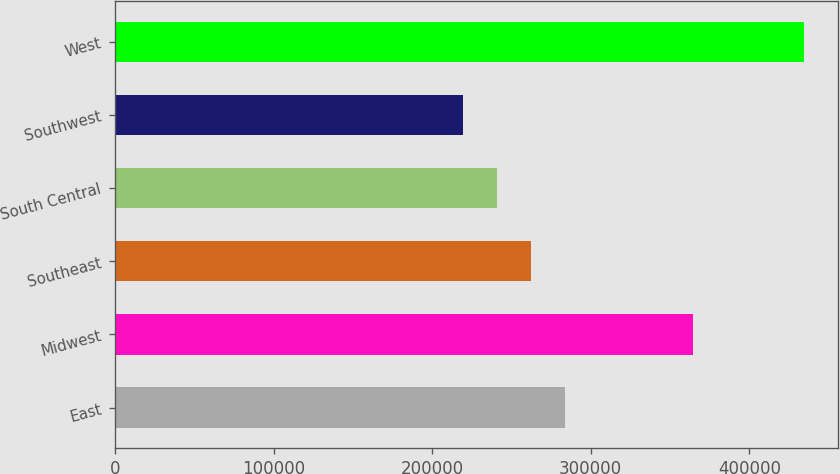<chart> <loc_0><loc_0><loc_500><loc_500><bar_chart><fcel>East<fcel>Midwest<fcel>Southeast<fcel>South Central<fcel>Southwest<fcel>West<nl><fcel>284050<fcel>364400<fcel>262600<fcel>241150<fcel>219700<fcel>434200<nl></chart> 